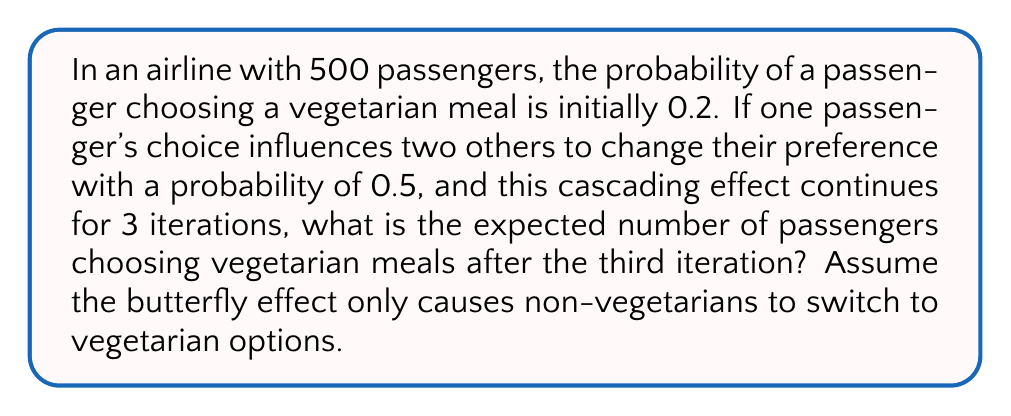Solve this math problem. Let's approach this step-by-step using concepts from chaos theory and probability:

1) Initially, the expected number of vegetarian meals is:
   $E_0 = 500 \times 0.2 = 100$

2) In each iteration, one vegetarian choice influences two others with a probability of 0.5. The expected number of new vegetarians per existing vegetarian is:
   $2 \times 0.5 = 1$

3) We can model this as a geometric series where each term is multiplied by 2 (as each new vegetarian can influence two more):

   $E_1 = E_0 + E_0 = 100 + 100 = 200$
   $E_2 = E_1 + 2E_0 = 200 + 200 = 400$
   $E_3 = E_2 + 4E_0 = 400 + 400 = 800$

4) However, we need to cap this at the total number of passengers (500). We can use the min function to achieve this:

   $E_3 = \min(500, 800) = 500$

Therefore, after the third iteration, we expect all 500 passengers to choose vegetarian meals due to the butterfly effect.
Answer: 500 